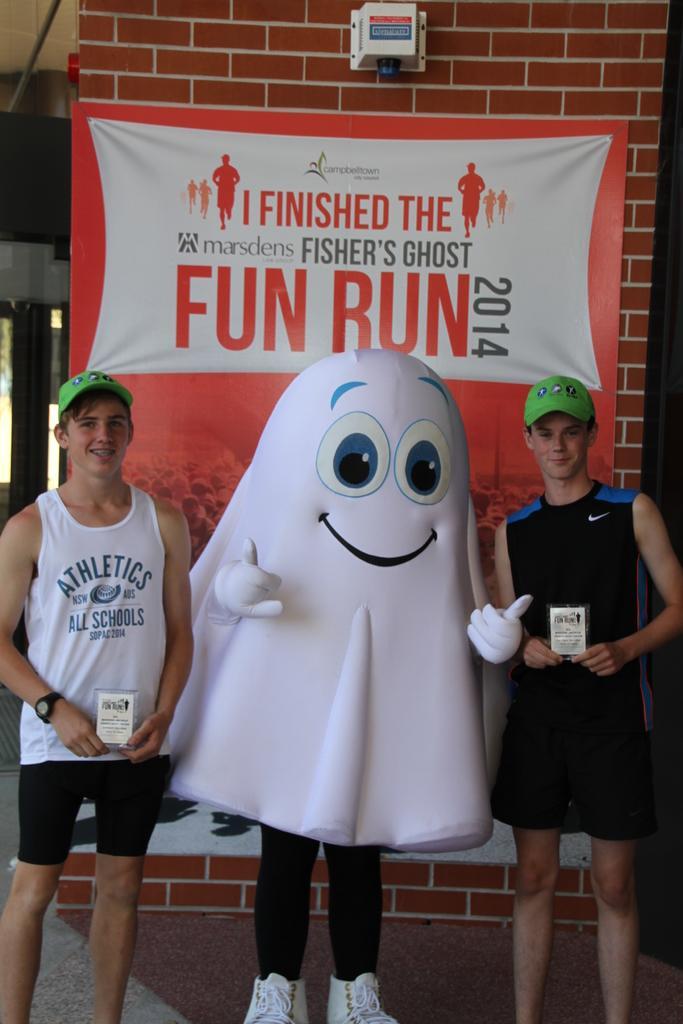How would you summarize this image in a sentence or two? In this we can see 2 boys standing and smiling at someone. They are posing with a man wearing a costume. 